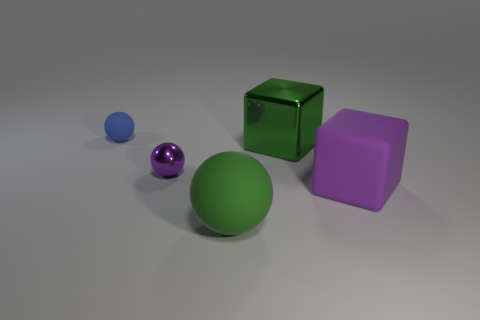What shape is the green thing that is behind the purple metal sphere?
Your response must be concise. Cube. What is the shape of the metallic thing that is the same color as the large rubber ball?
Ensure brevity in your answer.  Cube. What number of purple matte cubes have the same size as the blue object?
Offer a very short reply. 0. What is the color of the metallic block?
Your answer should be very brief. Green. There is a metal ball; is its color the same as the ball that is in front of the purple ball?
Provide a short and direct response. No. What size is the block that is the same material as the small purple sphere?
Your answer should be compact. Large. Are there any big matte cubes of the same color as the shiny block?
Your answer should be compact. No. How many things are rubber spheres in front of the small matte sphere or large gray balls?
Your answer should be compact. 1. Do the large purple cube and the large green ball on the left side of the purple rubber object have the same material?
Ensure brevity in your answer.  Yes. What is the size of the matte object that is the same color as the metallic sphere?
Provide a short and direct response. Large. 